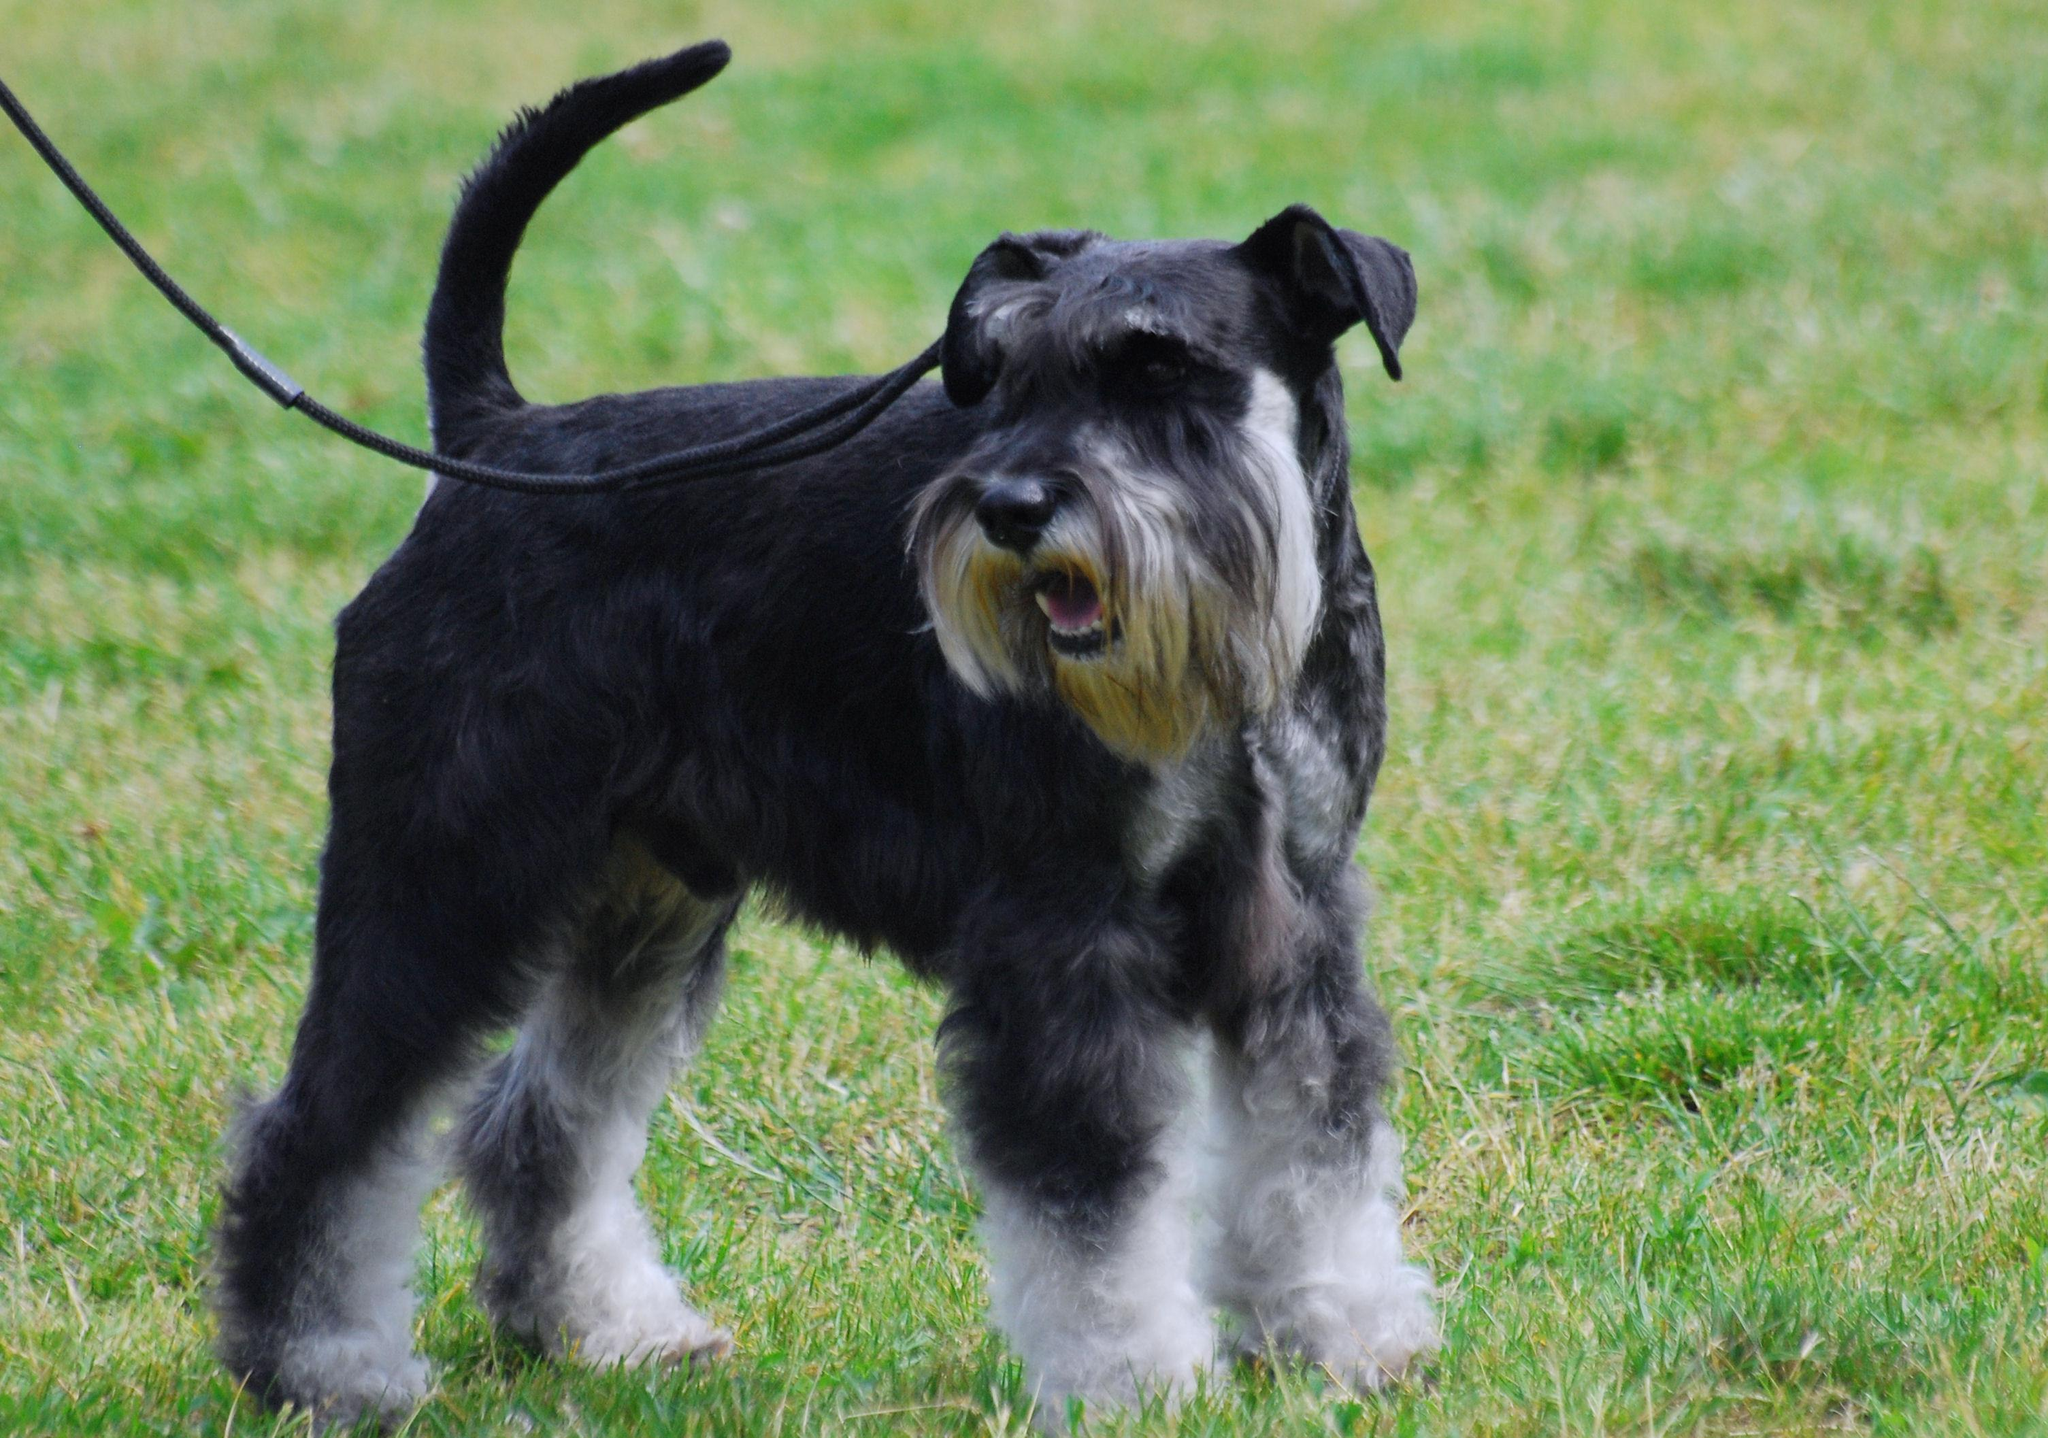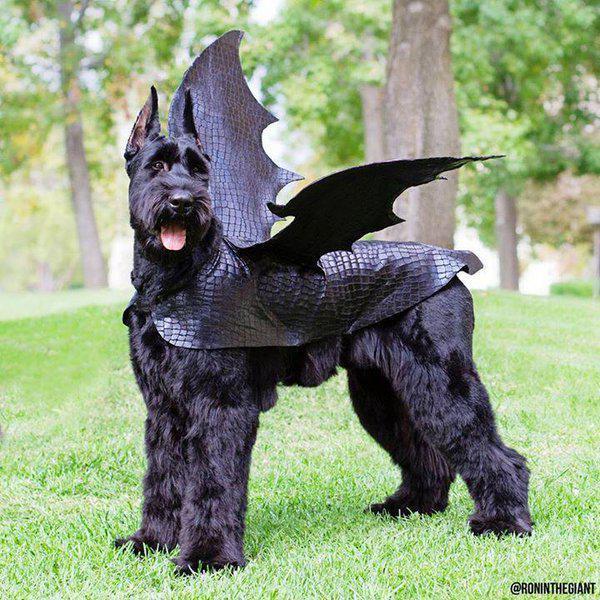The first image is the image on the left, the second image is the image on the right. Examine the images to the left and right. Is the description "One of the two dogs is NOT on a leash." accurate? Answer yes or no. Yes. 